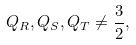<formula> <loc_0><loc_0><loc_500><loc_500>Q _ { R } , Q _ { S } , Q _ { T } \neq \frac { 3 } { 2 } ,</formula> 